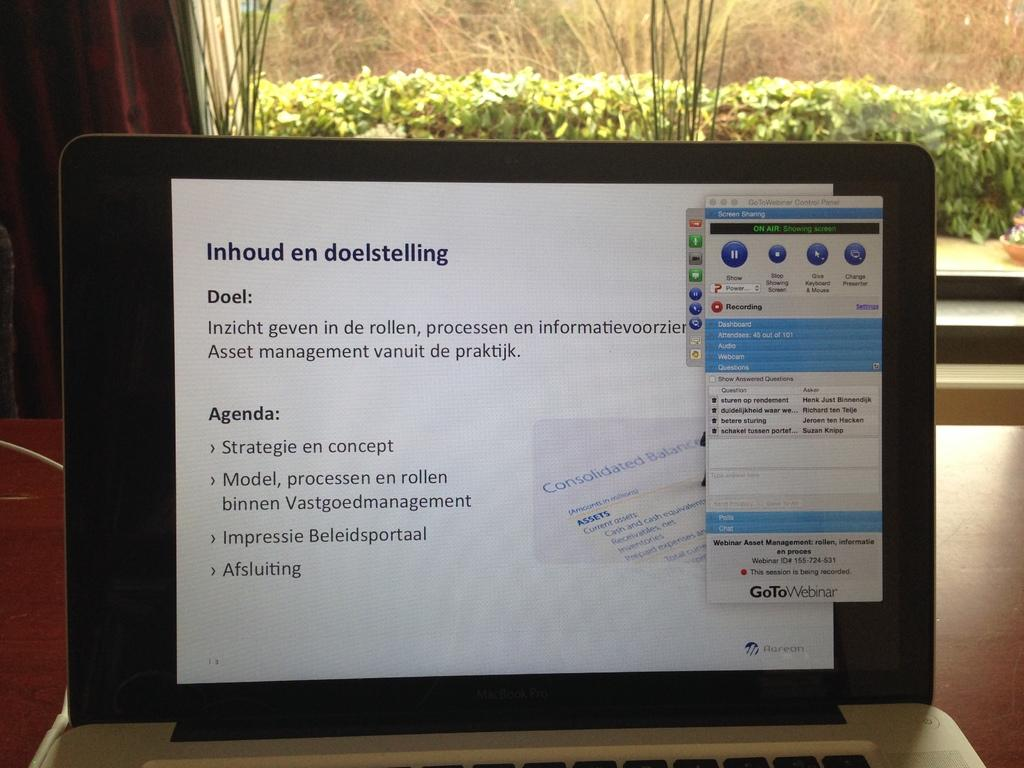<image>
Create a compact narrative representing the image presented. Laptop screen that starts off with "Inhoud en doelstelling". 